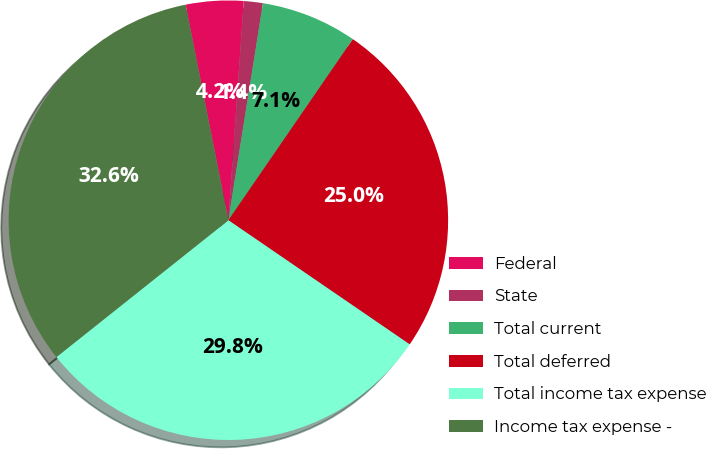Convert chart to OTSL. <chart><loc_0><loc_0><loc_500><loc_500><pie_chart><fcel>Federal<fcel>State<fcel>Total current<fcel>Total deferred<fcel>Total income tax expense<fcel>Income tax expense -<nl><fcel>4.23%<fcel>1.4%<fcel>7.07%<fcel>24.97%<fcel>29.75%<fcel>32.58%<nl></chart> 